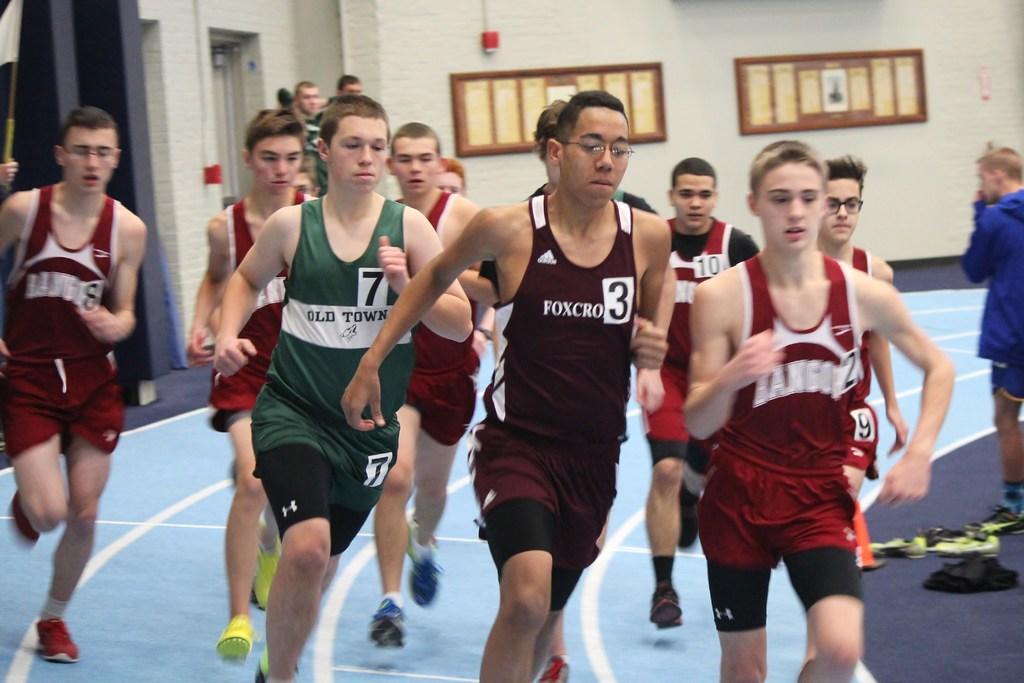Could you give a brief overview of what you see in this image? This image consists of many people running. They are wearing sports dress. At the bottom, there is ground. In the background, there is a wall on which boards are fixed. 